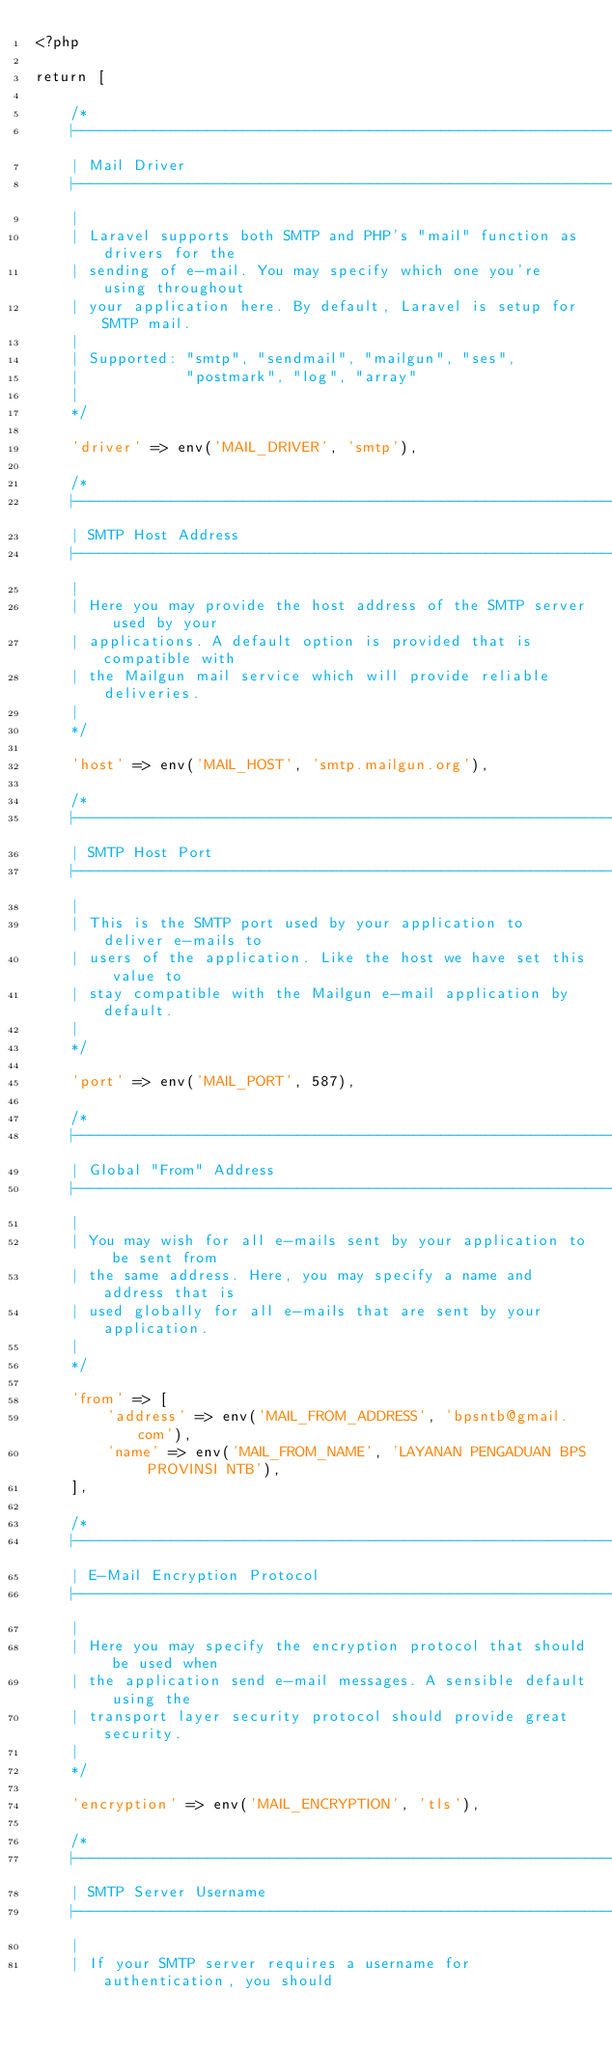<code> <loc_0><loc_0><loc_500><loc_500><_PHP_><?php

return [

    /*
    |--------------------------------------------------------------------------
    | Mail Driver
    |--------------------------------------------------------------------------
    |
    | Laravel supports both SMTP and PHP's "mail" function as drivers for the
    | sending of e-mail. You may specify which one you're using throughout
    | your application here. By default, Laravel is setup for SMTP mail.
    |
    | Supported: "smtp", "sendmail", "mailgun", "ses",
    |            "postmark", "log", "array"
    |
    */

    'driver' => env('MAIL_DRIVER', 'smtp'),

    /*
    |--------------------------------------------------------------------------
    | SMTP Host Address
    |--------------------------------------------------------------------------
    |
    | Here you may provide the host address of the SMTP server used by your
    | applications. A default option is provided that is compatible with
    | the Mailgun mail service which will provide reliable deliveries.
    |
    */

    'host' => env('MAIL_HOST', 'smtp.mailgun.org'),

    /*
    |--------------------------------------------------------------------------
    | SMTP Host Port
    |--------------------------------------------------------------------------
    |
    | This is the SMTP port used by your application to deliver e-mails to
    | users of the application. Like the host we have set this value to
    | stay compatible with the Mailgun e-mail application by default.
    |
    */

    'port' => env('MAIL_PORT', 587),

    /*
    |--------------------------------------------------------------------------
    | Global "From" Address
    |--------------------------------------------------------------------------
    |
    | You may wish for all e-mails sent by your application to be sent from
    | the same address. Here, you may specify a name and address that is
    | used globally for all e-mails that are sent by your application.
    |
    */

    'from' => [
        'address' => env('MAIL_FROM_ADDRESS', 'bpsntb@gmail.com'),
        'name' => env('MAIL_FROM_NAME', 'LAYANAN PENGADUAN BPS PROVINSI NTB'),
    ],

    /*
    |--------------------------------------------------------------------------
    | E-Mail Encryption Protocol
    |--------------------------------------------------------------------------
    |
    | Here you may specify the encryption protocol that should be used when
    | the application send e-mail messages. A sensible default using the
    | transport layer security protocol should provide great security.
    |
    */

    'encryption' => env('MAIL_ENCRYPTION', 'tls'),

    /*
    |--------------------------------------------------------------------------
    | SMTP Server Username
    |--------------------------------------------------------------------------
    |
    | If your SMTP server requires a username for authentication, you should</code> 